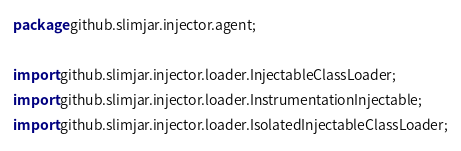Convert code to text. <code><loc_0><loc_0><loc_500><loc_500><_Java_>package github.slimjar.injector.agent;

import github.slimjar.injector.loader.InjectableClassLoader;
import github.slimjar.injector.loader.InstrumentationInjectable;
import github.slimjar.injector.loader.IsolatedInjectableClassLoader;</code> 